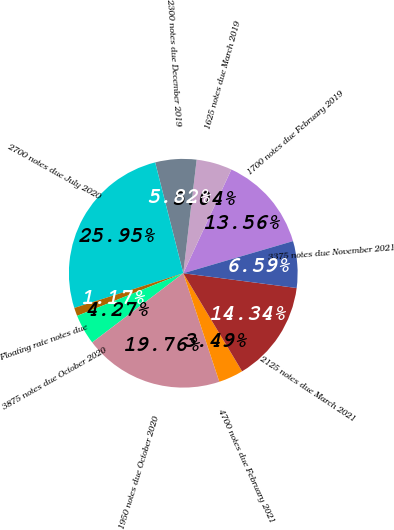<chart> <loc_0><loc_0><loc_500><loc_500><pie_chart><fcel>1700 notes due February 2019<fcel>1625 notes due March 2019<fcel>2300 notes due December 2019<fcel>2700 notes due July 2020<fcel>Floating rate notes due<fcel>3875 notes due October 2020<fcel>1950 notes due October 2020<fcel>4700 notes due February 2021<fcel>2125 notes due March 2021<fcel>3375 notes due November 2021<nl><fcel>13.56%<fcel>5.04%<fcel>5.82%<fcel>25.95%<fcel>1.17%<fcel>4.27%<fcel>19.76%<fcel>3.49%<fcel>14.34%<fcel>6.59%<nl></chart> 